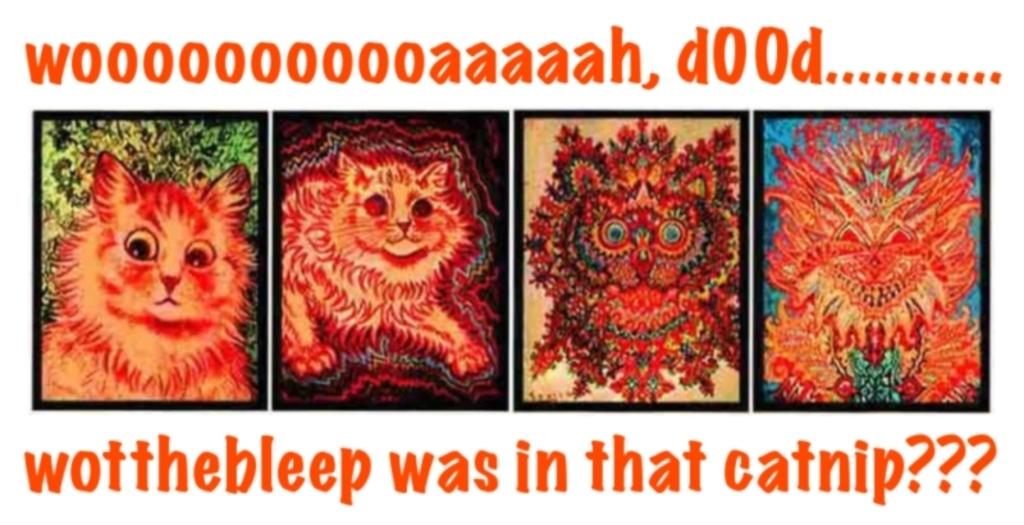What is the main subject of the image? The main subject of the image is cartoon pictures. Where are the cartoon pictures located in the image? The cartoon pictures are in the middle of the image. What else can be seen in the image besides the cartoon pictures? There is text at the top and bottom of the image. What type of cap is being worn by the cartoon character in the image? There is no cartoon character wearing a cap in the image, as the main subject is cartoon pictures rather than individual characters. 